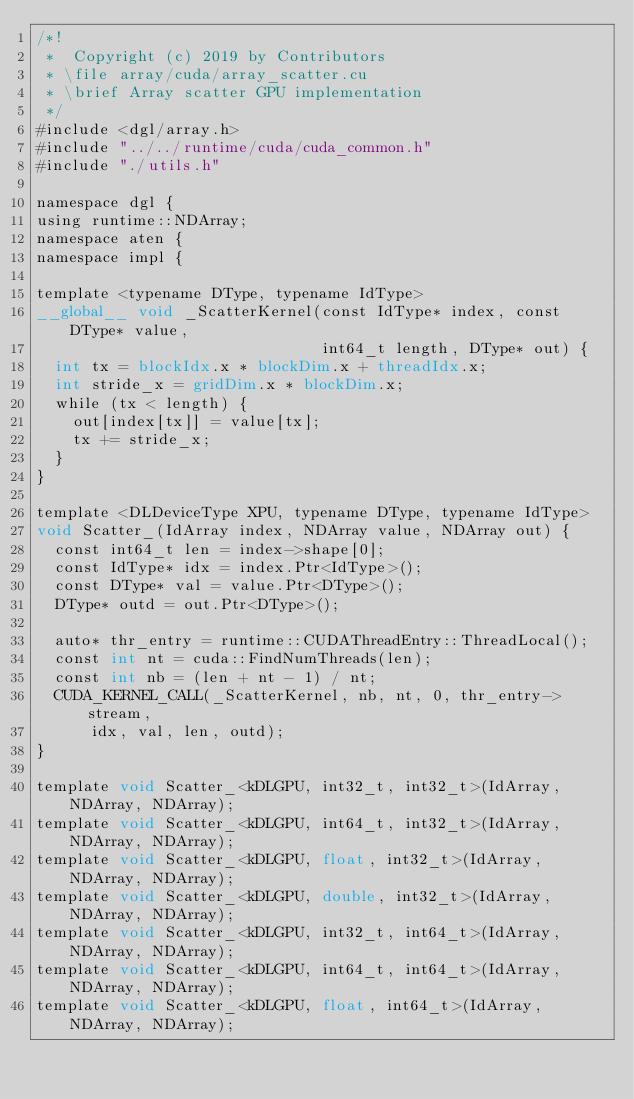<code> <loc_0><loc_0><loc_500><loc_500><_Cuda_>/*!
 *  Copyright (c) 2019 by Contributors
 * \file array/cuda/array_scatter.cu
 * \brief Array scatter GPU implementation
 */
#include <dgl/array.h>
#include "../../runtime/cuda/cuda_common.h"
#include "./utils.h"

namespace dgl {
using runtime::NDArray;
namespace aten {
namespace impl {

template <typename DType, typename IdType>
__global__ void _ScatterKernel(const IdType* index, const DType* value,
                               int64_t length, DType* out) {
  int tx = blockIdx.x * blockDim.x + threadIdx.x;
  int stride_x = gridDim.x * blockDim.x;
  while (tx < length) {
    out[index[tx]] = value[tx];
    tx += stride_x;
  }
}

template <DLDeviceType XPU, typename DType, typename IdType>
void Scatter_(IdArray index, NDArray value, NDArray out) {
  const int64_t len = index->shape[0];
  const IdType* idx = index.Ptr<IdType>();
  const DType* val = value.Ptr<DType>();
  DType* outd = out.Ptr<DType>();

  auto* thr_entry = runtime::CUDAThreadEntry::ThreadLocal();
  const int nt = cuda::FindNumThreads(len);
  const int nb = (len + nt - 1) / nt;
  CUDA_KERNEL_CALL(_ScatterKernel, nb, nt, 0, thr_entry->stream,
      idx, val, len, outd);
}

template void Scatter_<kDLGPU, int32_t, int32_t>(IdArray, NDArray, NDArray);
template void Scatter_<kDLGPU, int64_t, int32_t>(IdArray, NDArray, NDArray);
template void Scatter_<kDLGPU, float, int32_t>(IdArray, NDArray, NDArray);
template void Scatter_<kDLGPU, double, int32_t>(IdArray, NDArray, NDArray);
template void Scatter_<kDLGPU, int32_t, int64_t>(IdArray, NDArray, NDArray);
template void Scatter_<kDLGPU, int64_t, int64_t>(IdArray, NDArray, NDArray);
template void Scatter_<kDLGPU, float, int64_t>(IdArray, NDArray, NDArray);</code> 